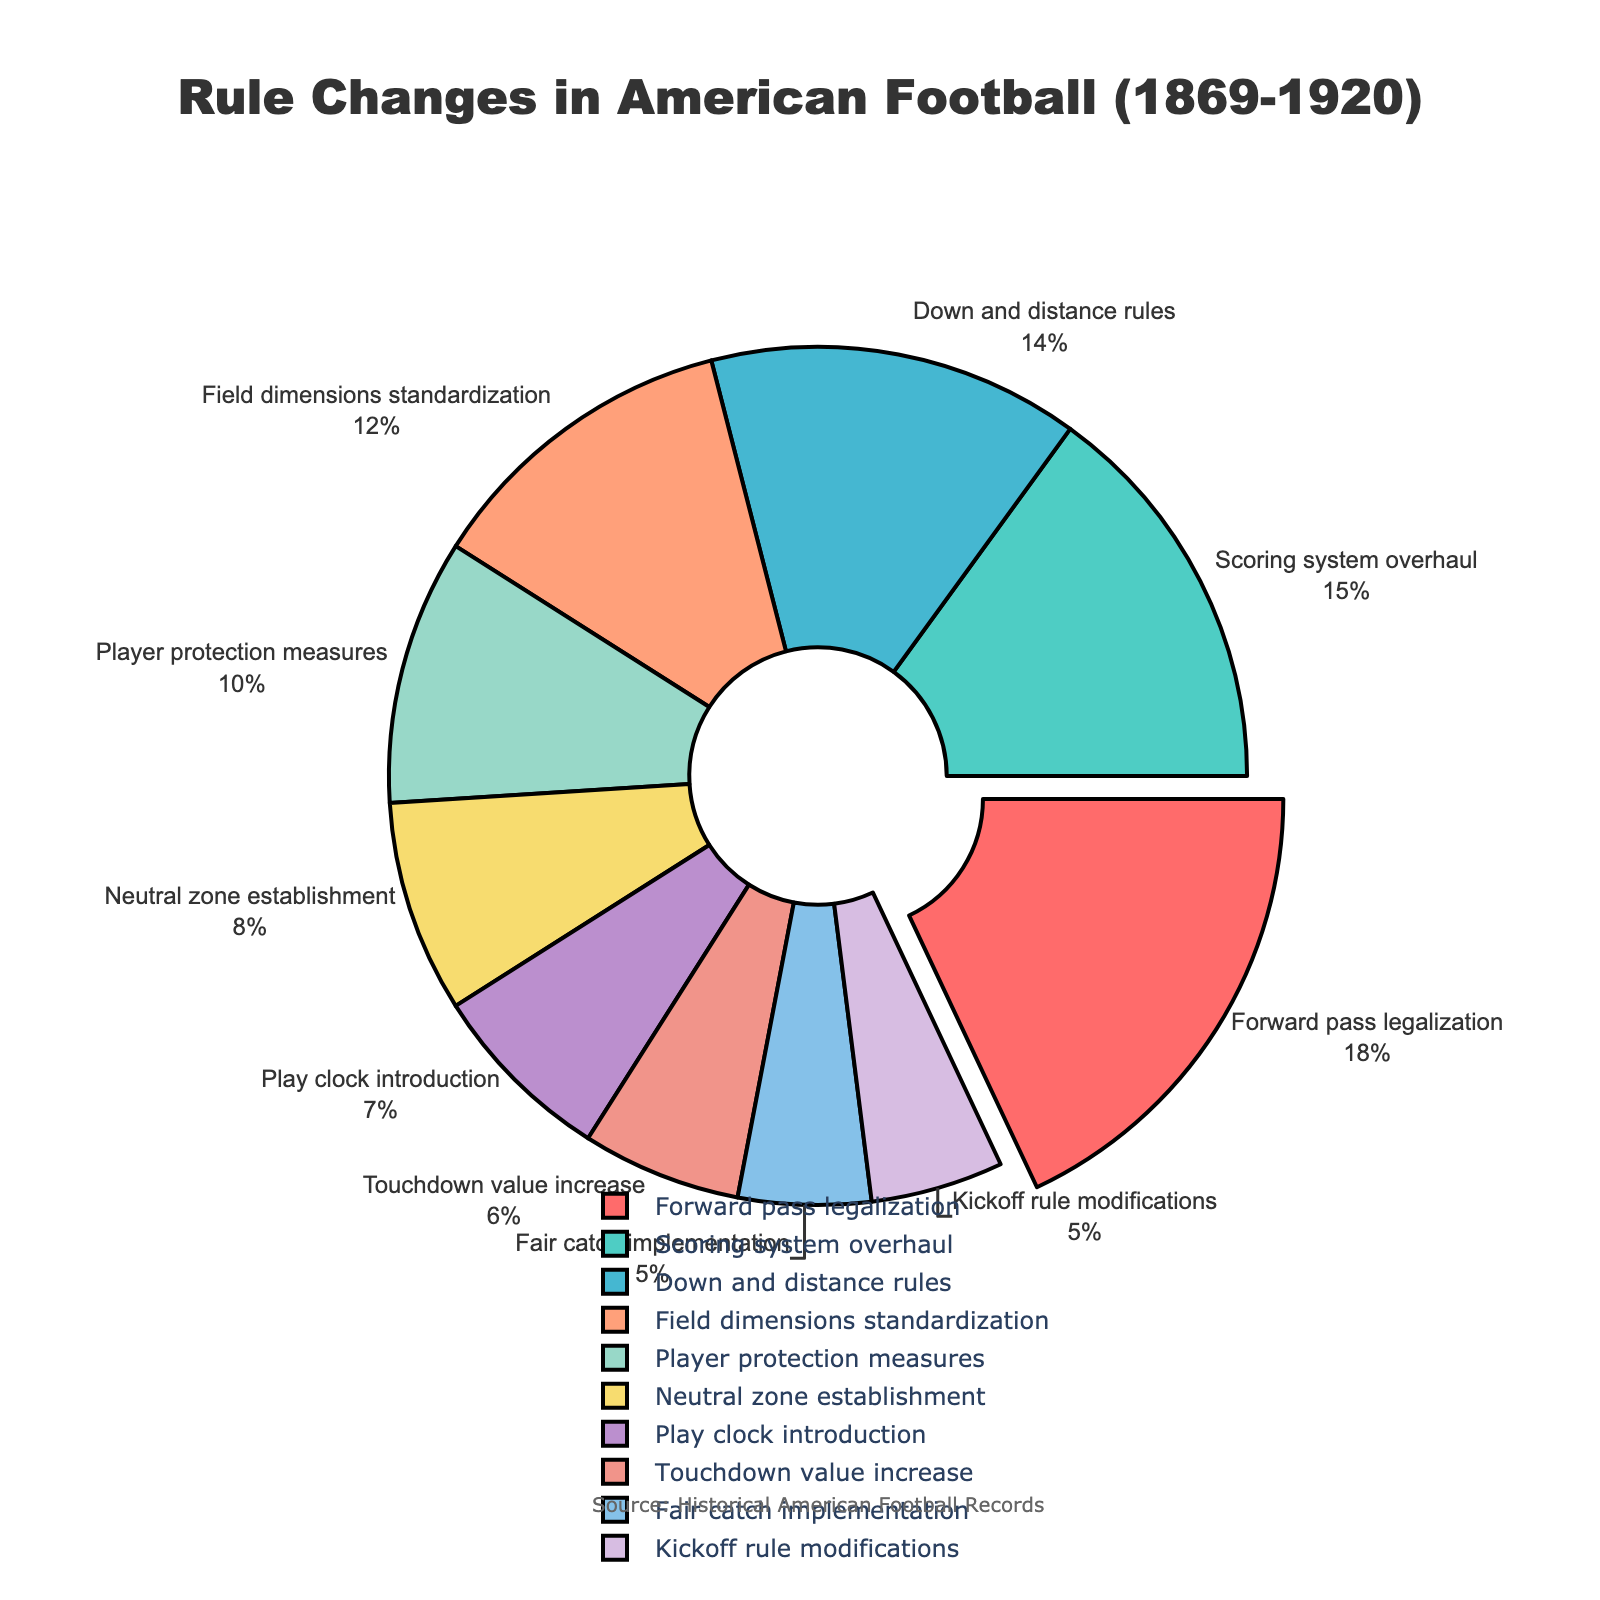What is the percentage of rule changes for Forward pass legalization? The pie chart shows that the Forward pass legalization accounts for 18% of the rule changes.
Answer: 18% Which rule change has the highest percentage? By looking at the pie chart, it is clear that the Forward pass legalization has the highest percentage.
Answer: Forward pass legalization How much greater is the percentage of the Scoring system overhaul compared to the Kickoff rule modifications? The Scoring system overhaul is 15% and the Kickoff rule modifications are 5%. The difference is 15% - 5% = 10%.
Answer: 10% Which rule change categories have the same percentage value? Observing the pie chart, both Fair catch implementation and Kickoff rule modifications have a percentage of 5%.
Answer: Fair catch implementation and Kickoff rule modifications What is the combined percentage of Player protection measures and Field dimensions standardization? The percentage for Player protection measures is 10% and for Field dimensions standardization is 12%. Adding these percentages, we get 10% + 12% = 22%.
Answer: 22% Which category is represented by the color red? From the visual attributes of the pie chart, the color red represents Forward pass legalization.
Answer: Forward pass legalization What is the total percentage of rule changes associated with gameplay tactics (Forward pass legalization and Down and distance rules)? Forward pass legalization is 18% and Down and distance rules is 14%. Adding these percentages, 18% + 14% = 32%.
Answer: 32% How does the percentage of the Neutral zone establishment compare to the introduction of the Play clock? The Neutral zone establishment is 8% and the Play clock introduction is 7%. Thus, the Neutral zone establishment is 1% greater than the Play clock introduction.
Answer: Neutral zone establishment is 1% greater What is the difference in percentage between the highest and lowest rule changes? The highest percentage is Forward pass legalization at 18% and the lowest percentages are Fair catch implementation and Kickoff rule modifications at 5%. The difference is 18% - 5% = 13%.
Answer: 13% Calculate the average percentage of all categories listed. Summing up all the percentages: 18 + 15 + 14 + 12 + 10 + 8 + 7 + 6 + 5 + 5 = 100. The average is 100% / 10 categories = 10%.
Answer: 10% 